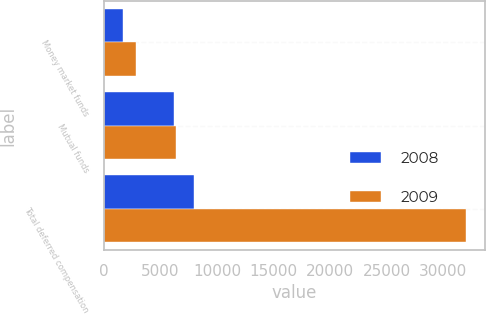Convert chart to OTSL. <chart><loc_0><loc_0><loc_500><loc_500><stacked_bar_chart><ecel><fcel>Money market funds<fcel>Mutual funds<fcel>Total deferred compensation<nl><fcel>2008<fcel>1730<fcel>6213<fcel>7943<nl><fcel>2009<fcel>2841<fcel>6415<fcel>32041<nl></chart> 